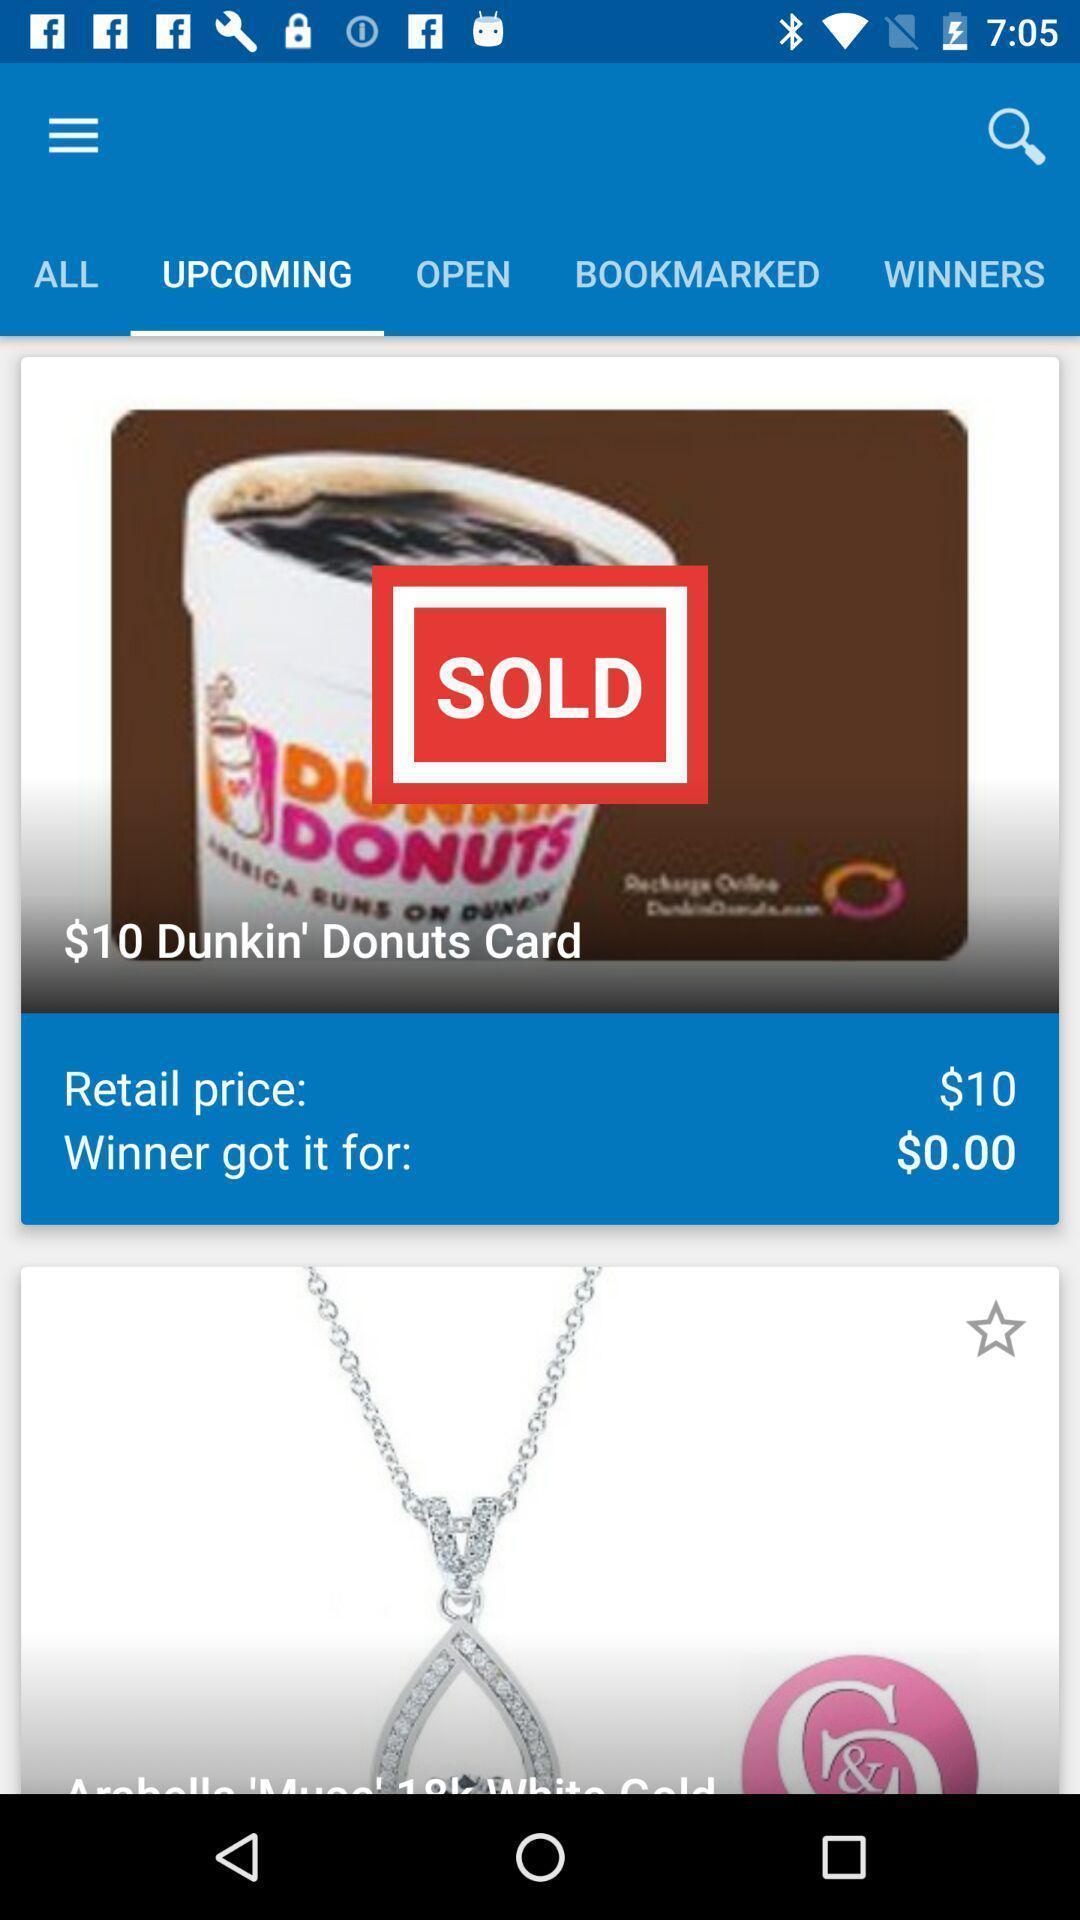Explain what's happening in this screen capture. Page showing the upcoming items. 